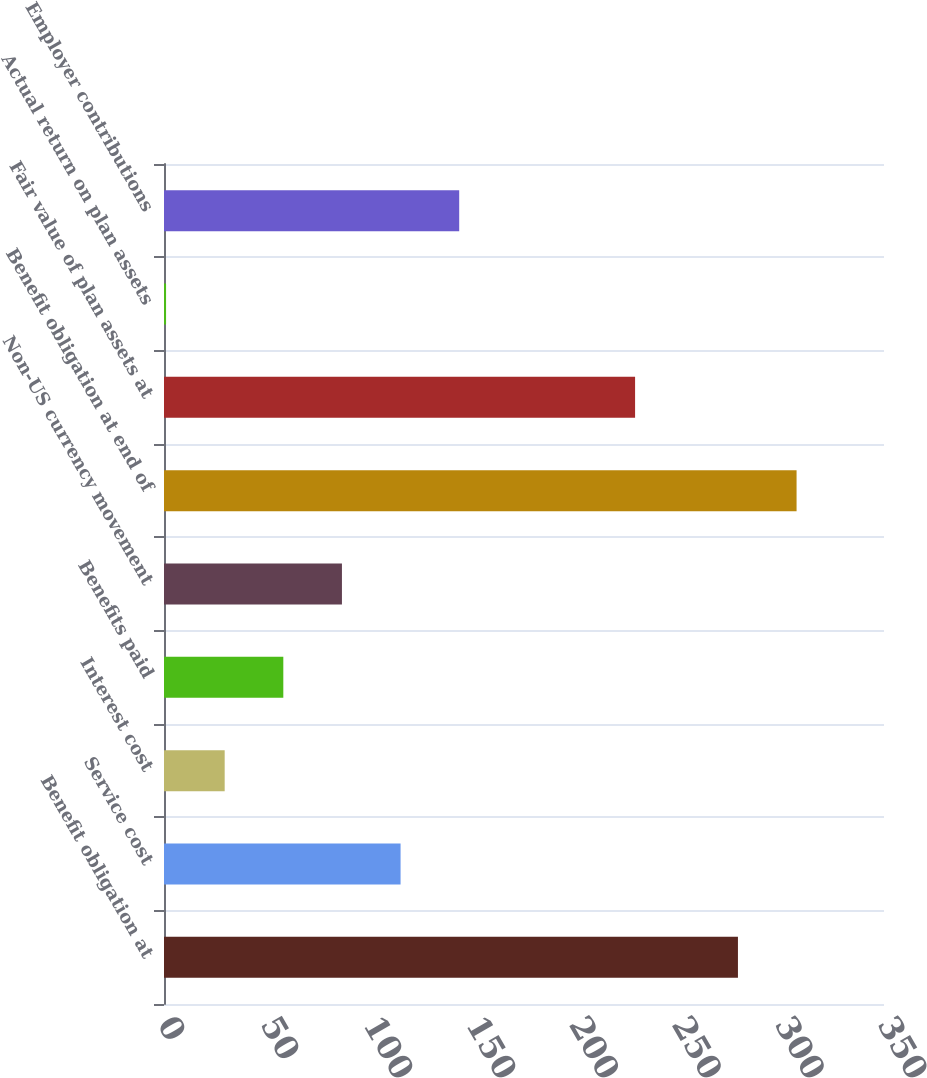<chart> <loc_0><loc_0><loc_500><loc_500><bar_chart><fcel>Benefit obligation at<fcel>Service cost<fcel>Interest cost<fcel>Benefits paid<fcel>Non-US currency movement<fcel>Benefit obligation at end of<fcel>Fair value of plan assets at<fcel>Actual return on plan assets<fcel>Employer contributions<nl><fcel>279<fcel>115<fcel>29.5<fcel>58<fcel>86.5<fcel>307.5<fcel>229<fcel>1<fcel>143.5<nl></chart> 